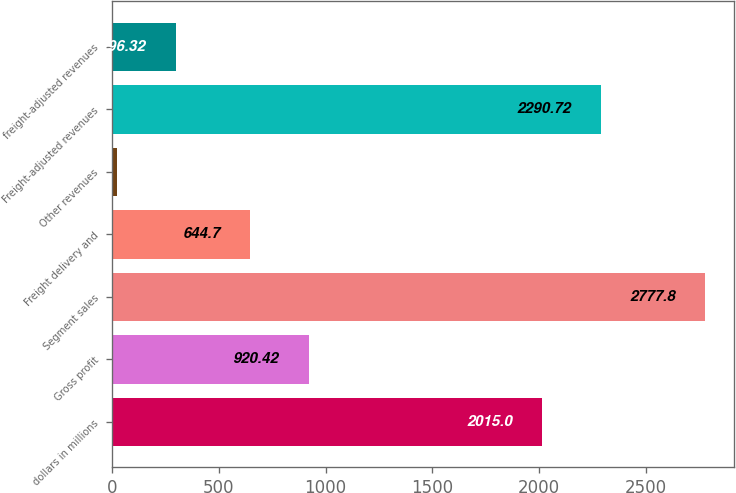Convert chart. <chart><loc_0><loc_0><loc_500><loc_500><bar_chart><fcel>dollars in millions<fcel>Gross profit<fcel>Segment sales<fcel>Freight delivery and<fcel>Other revenues<fcel>Freight-adjusted revenues<fcel>freight-adjusted revenues<nl><fcel>2015<fcel>920.42<fcel>2777.8<fcel>644.7<fcel>20.6<fcel>2290.72<fcel>296.32<nl></chart> 